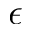<formula> <loc_0><loc_0><loc_500><loc_500>\epsilon</formula> 